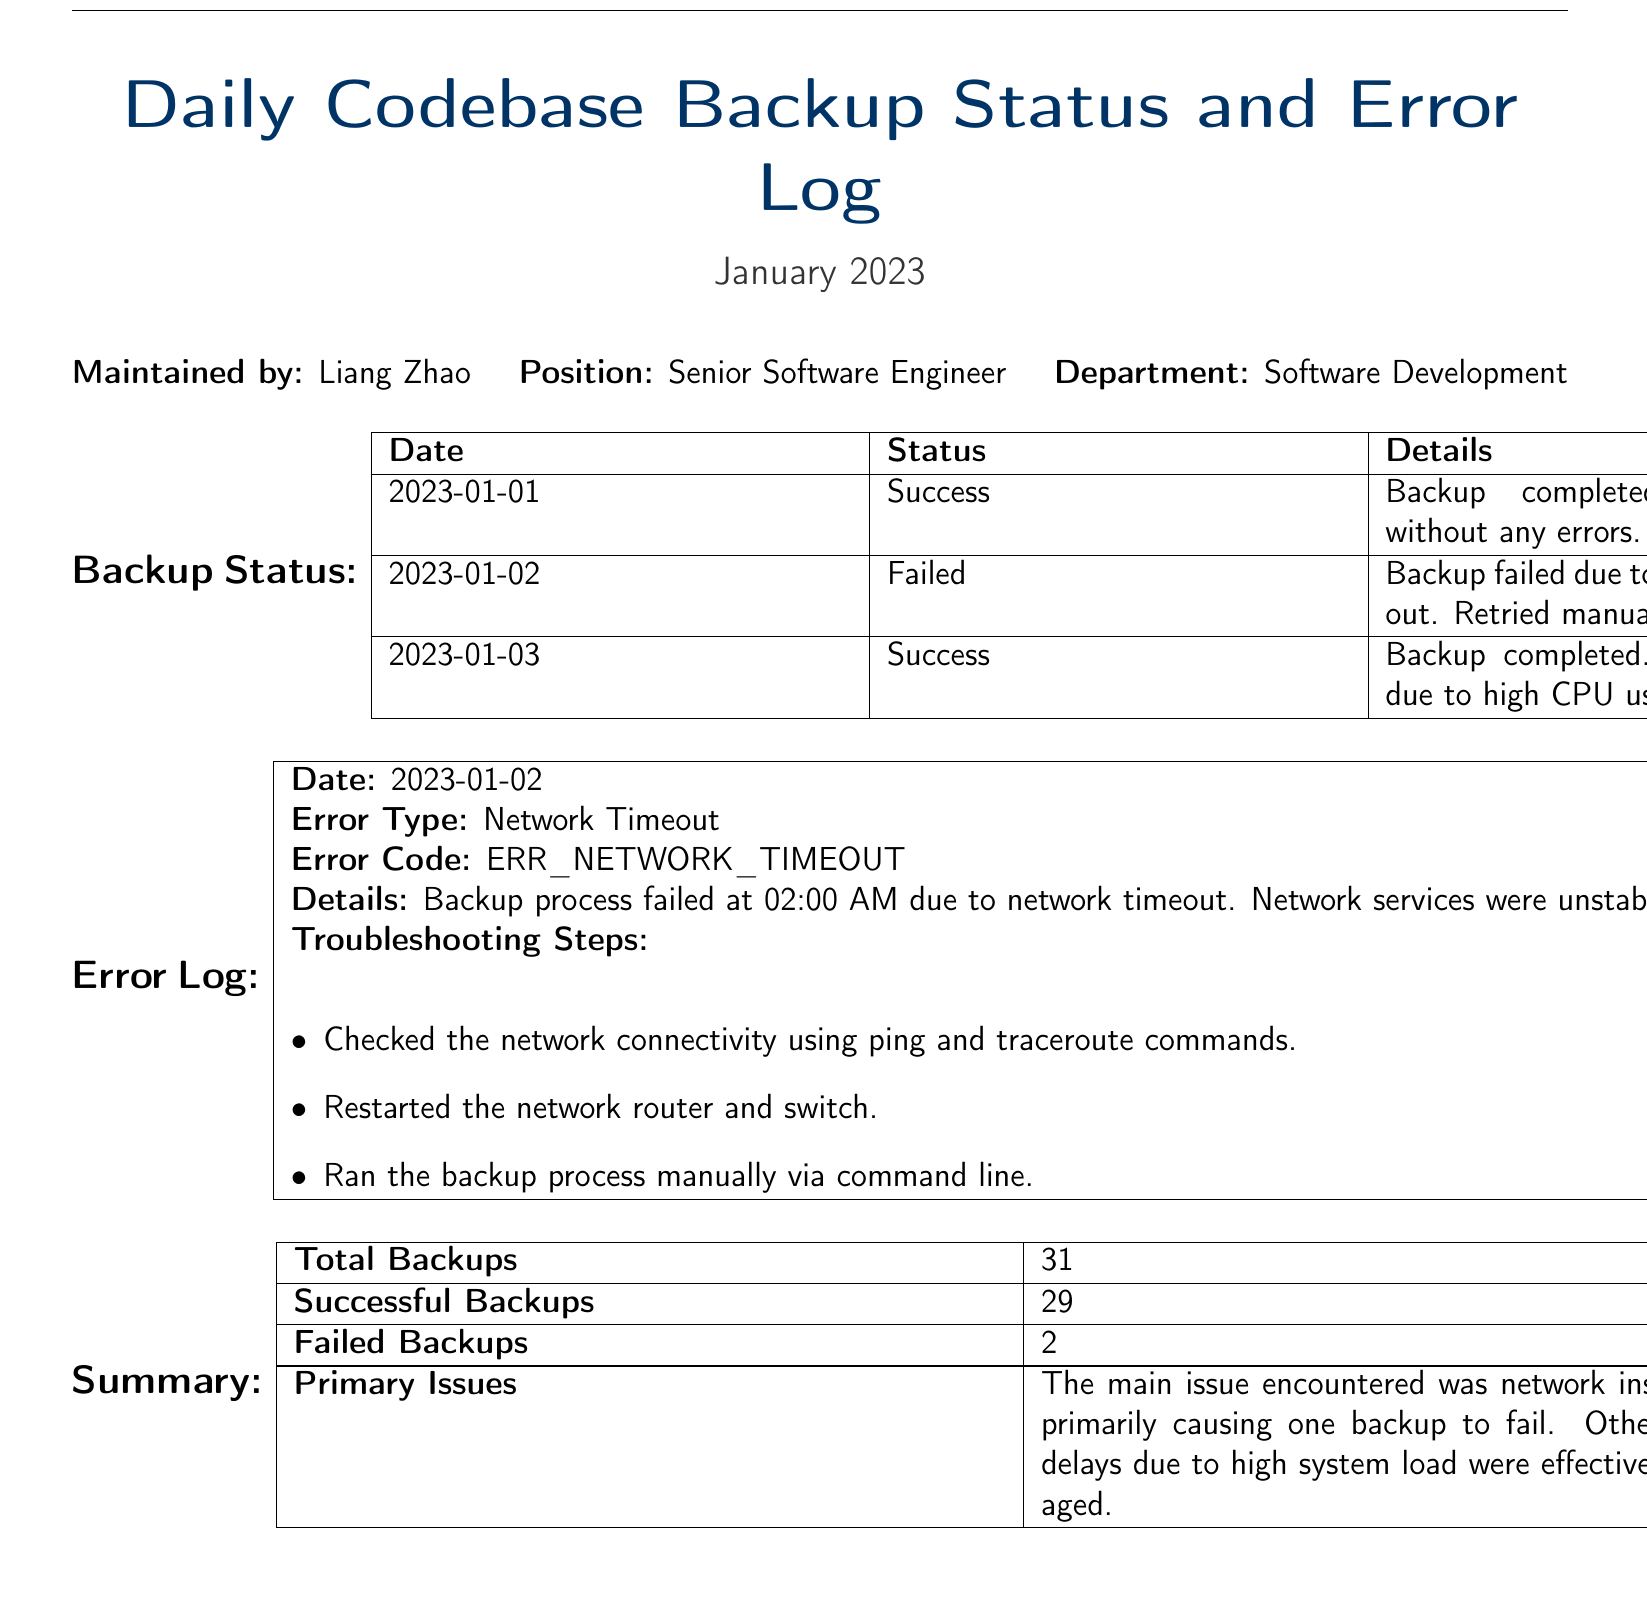What date did the backup fail? The document indicates that the backup failed on 2023-01-02.
Answer: 2023-01-02 How many total backups were conducted in January 2023? The total number of backups is explicitly stated in the summary section of the document.
Answer: 31 What was the status of the backup on January 1st, 2023? The status is provided in the backup status table, indicating that the backup was successful.
Answer: Success What was the primary issue that caused backup failures? The summary section explains that the main issue was network instability.
Answer: Network instability What error code was associated with the backup failure on January 2nd, 2023? The document specifies the error code related to the January 2nd backup failure.
Answer: ERR_NETWORK_TIMEOUT How many backups were successful in January 2023? The successful backups count is provided in the summary table of the document.
Answer: 29 What troubleshooting step was taken regarding the network? The error log mentions checking network connectivity as a troubleshooting step.
Answer: Checked the network connectivity When was the backup process manually run again? The error log indicates the backup process was retried manually after the network timeout dealt with the failed backup on January 2nd.
Answer: After network timeout What was the backup completion time on January 2nd? The document states that the backup process failed at 02:00 AM on that date.
Answer: 02:00 AM 